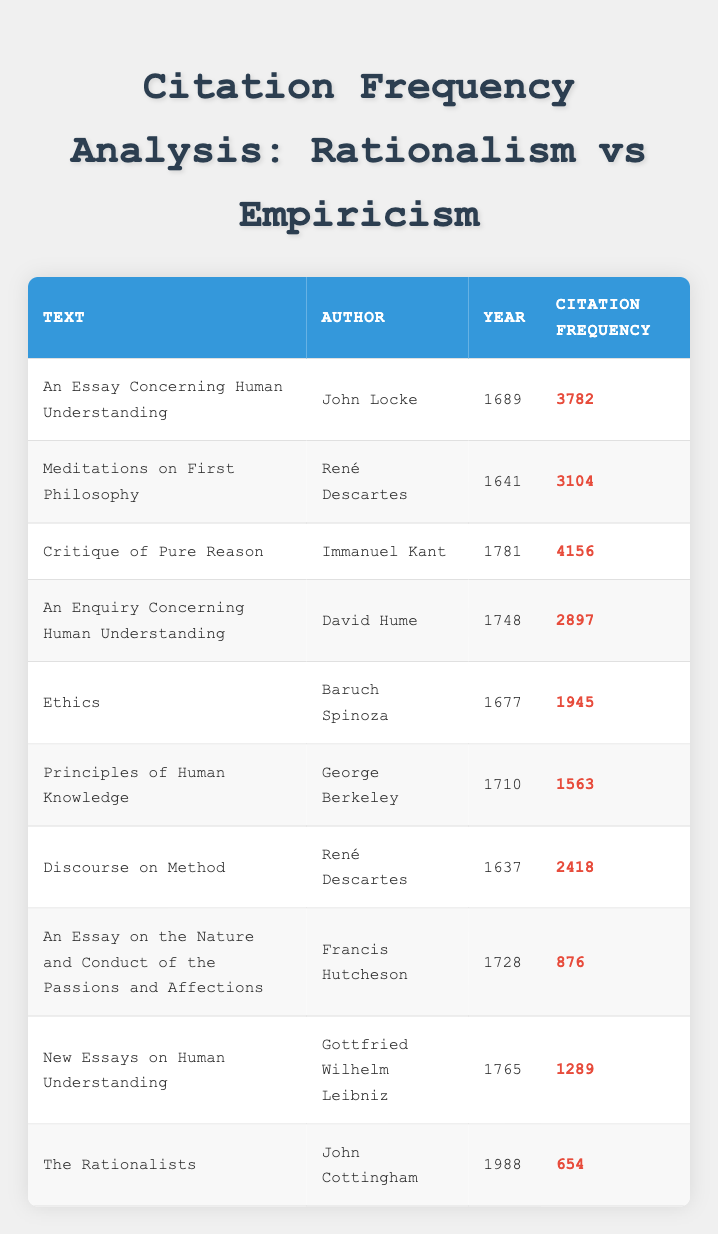What is the citation frequency of "Critique of Pure Reason"? The citation frequency can be found directly in the table under the "Citation Frequency" column for "Critique of Pure Reason". It shows 4156 citations.
Answer: 4156 Who is the author of "An Enquiry Concerning Human Understanding"? The author's name is listed in the same row as the title "An Enquiry Concerning Human Understanding" in the table, identified as David Hume.
Answer: David Hume How many citations does "Ethics" have compared to "Principles of Human Knowledge"? "Ethics" has 1945 citations, while "Principles of Human Knowledge" has 1563 citations. To find the difference, subtract 1563 from 1945, resulting in 382 more citations for "Ethics".
Answer: 382 Is "Discourse on Method" cited more frequently than "New Essays on Human Understanding"? Checking the citation frequencies: "Discourse on Method" has 2418 citations and "New Essays on Human Understanding" has 1289 citations. Since 2418 is greater than 1289, the answer is yes.
Answer: Yes What is the average citation frequency of the texts authored by René Descartes? René Descartes has two texts: "Meditations on First Philosophy" with 3104 citations and "Discourse on Method" with 2418 citations. To find the average, add these two values (3104 + 2418 = 5522) and divide by the number of texts (5522 / 2 = 2761).
Answer: 2761 Which text has the highest citation frequency and what is its frequency? The highest citation frequency must be determined by comparing all the values in the "Citation Frequency" column. "Critique of Pure Reason" has the highest at 4156 citations, more than any other text.
Answer: 4156 Which author has the least cited work based on this table? The work with the least citation frequency must be identified by reviewing the "Citation Frequency" column. "The Rationalists" by John Cottingham has the lowest frequency at 654. Therefore, John Cottingham is the author of the least cited work.
Answer: John Cottingham What is the total citation frequency for all the texts listed? To find the total, sum all the citation frequencies from the table: 3782 + 3104 + 4156 + 2897 + 1945 + 1563 + 2418 + 876 + 1289 + 654, resulting in a total of 20884 citations.
Answer: 20884 How many texts were published before the year 1700? The publications before 1700 include "Meditations on First Philosophy" (1641), "Ethics" (1677), "An Essay Concerning Human Understanding" (1689), and "Discourse on Method" (1637). Counting them gives us a total of 4 texts.
Answer: 4 